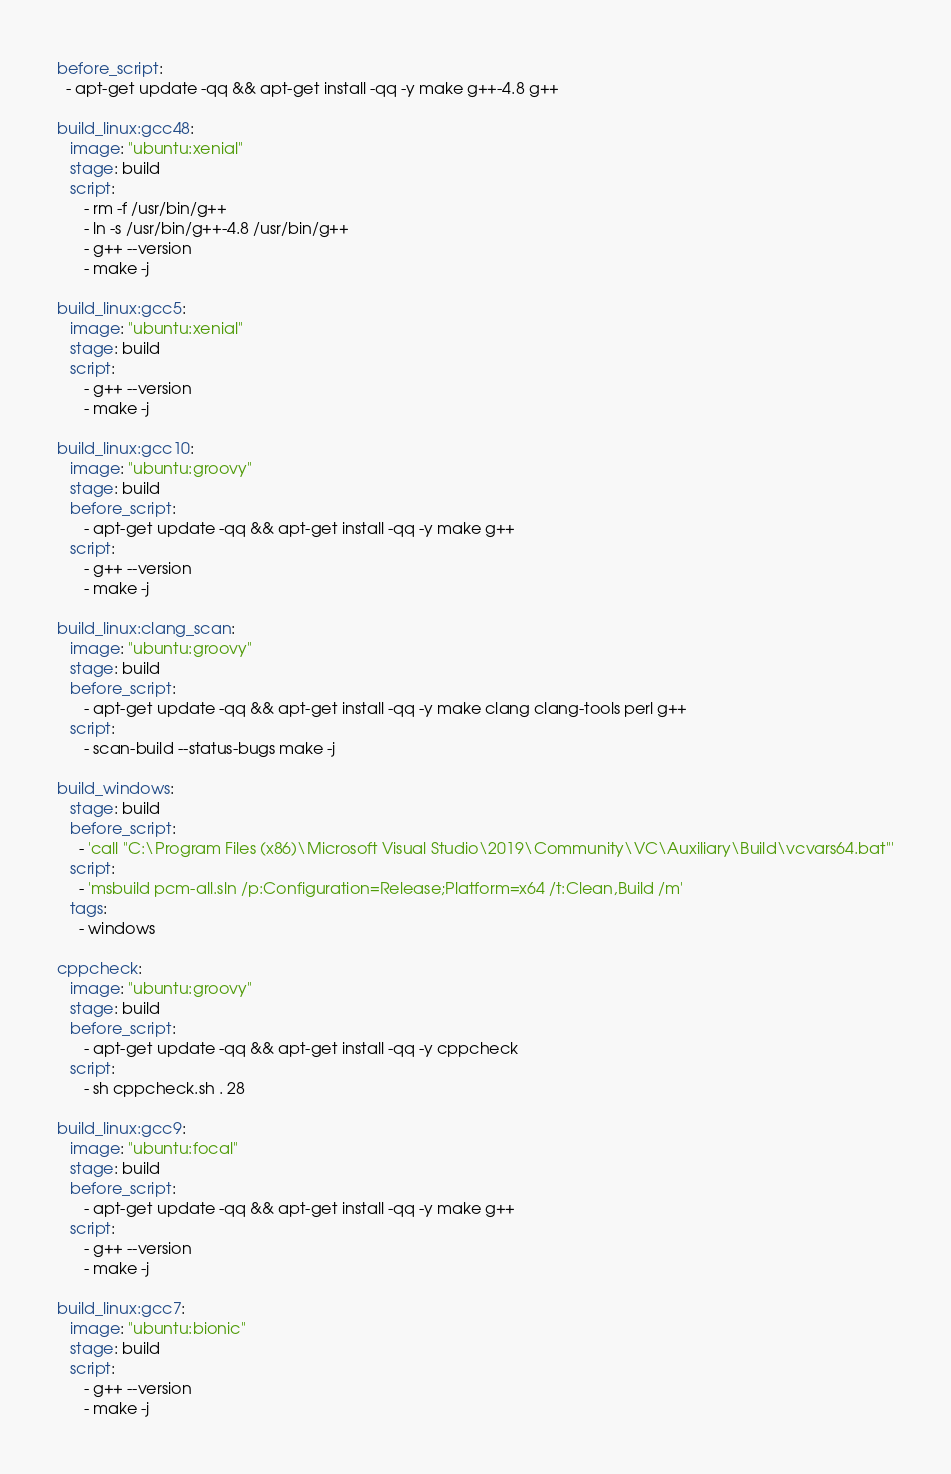<code> <loc_0><loc_0><loc_500><loc_500><_YAML_>before_script:
  - apt-get update -qq && apt-get install -qq -y make g++-4.8 g++

build_linux:gcc48:
   image: "ubuntu:xenial"
   stage: build
   script:
      - rm -f /usr/bin/g++
      - ln -s /usr/bin/g++-4.8 /usr/bin/g++
      - g++ --version
      - make -j

build_linux:gcc5:
   image: "ubuntu:xenial"
   stage: build
   script:
      - g++ --version
      - make -j

build_linux:gcc10:
   image: "ubuntu:groovy"
   stage: build
   before_script:
      - apt-get update -qq && apt-get install -qq -y make g++
   script:
      - g++ --version
      - make -j

build_linux:clang_scan:
   image: "ubuntu:groovy"
   stage: build
   before_script:
      - apt-get update -qq && apt-get install -qq -y make clang clang-tools perl g++
   script:
      - scan-build --status-bugs make -j

build_windows:
   stage: build
   before_script:
     - 'call "C:\Program Files (x86)\Microsoft Visual Studio\2019\Community\VC\Auxiliary\Build\vcvars64.bat"'
   script:
     - 'msbuild pcm-all.sln /p:Configuration=Release;Platform=x64 /t:Clean,Build /m'
   tags:
     - windows

cppcheck:
   image: "ubuntu:groovy"
   stage: build
   before_script:
      - apt-get update -qq && apt-get install -qq -y cppcheck
   script:
      - sh cppcheck.sh . 28

build_linux:gcc9:
   image: "ubuntu:focal"
   stage: build
   before_script:
      - apt-get update -qq && apt-get install -qq -y make g++
   script:
      - g++ --version
      - make -j

build_linux:gcc7:
   image: "ubuntu:bionic"
   stage: build
   script:
      - g++ --version
      - make -j
</code> 